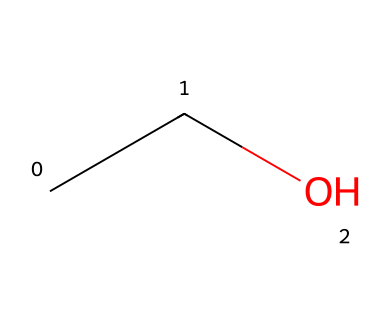What is the name of this chemical? The SMILES representation "CCO" corresponds to ethanol, as it shows the molecular structure of two carbon atoms (C) and one oxygen atom (O) connected in a linear fashion.
Answer: ethanol How many carbon atoms are in this compound? In the SMILES representation "CCO", the "C" is repeated twice, indicating there are two carbon atoms in the structure.
Answer: 2 What is the functional group present in this molecule? The presence of the "OH" part of the molecule (specifically in the "C" connected to "O") indicates that this compound has a hydroxyl functional group, which is characteristic of alcohols.
Answer: hydroxyl What is the total number of hydrogen atoms in ethanol? Based on the structure provided in the SMILES "CCO", each carbon typically bonds to 2 or 3 hydrogen atoms, and the specific arrangement leads to a total of 6 hydrogen atoms when calculated in a fully saturated scenario.
Answer: 6 Is ethanol polar or non-polar? Ethanol contains a hydroxyl group, which is polar due to the difference in electronegativity between oxygen and hydrogen, leading to its overall polar nature.
Answer: polar What type of solvent is ethanol classified as? Ethanol is commonly classified as a polar solvent due to its ability to dissolve many ionic and polar compounds, making it effective in various applications, including conservation.
Answer: polar solvent 